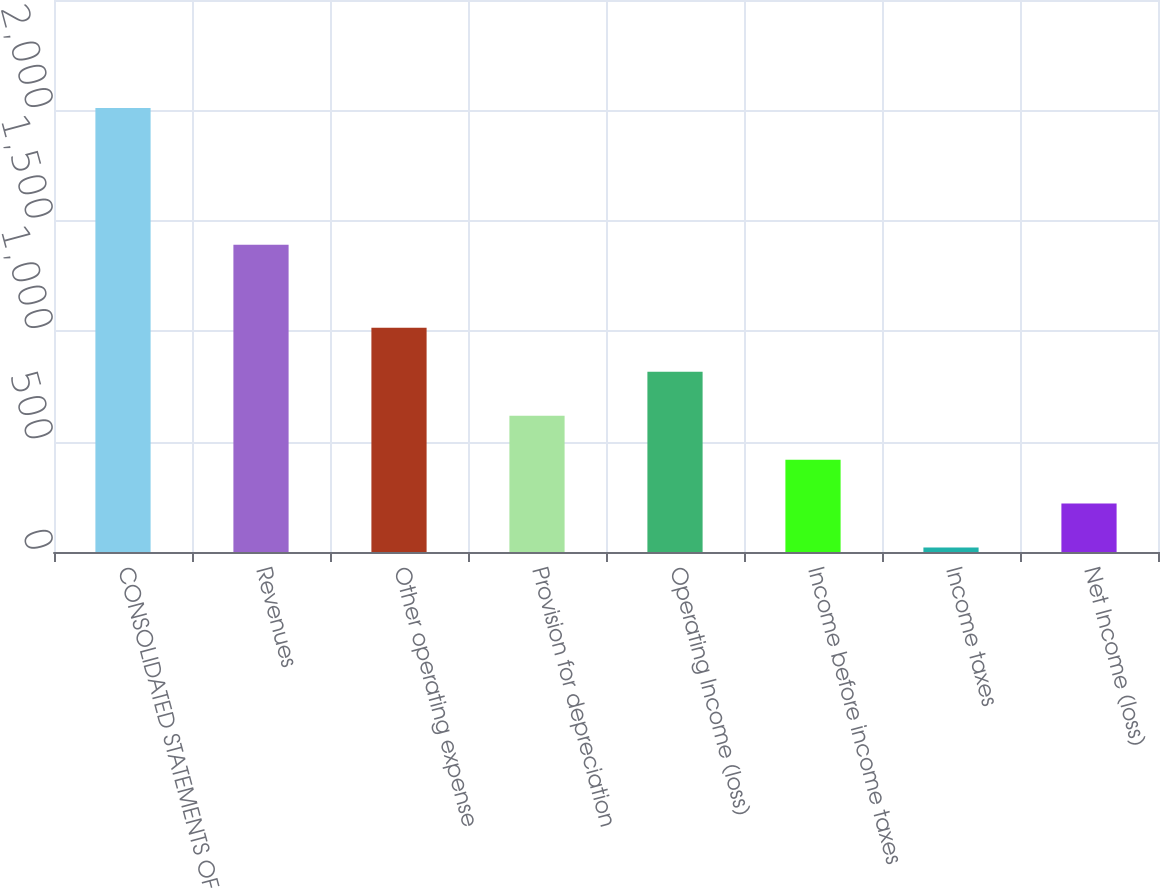<chart> <loc_0><loc_0><loc_500><loc_500><bar_chart><fcel>CONSOLIDATED STATEMENTS OF<fcel>Revenues<fcel>Other operating expense<fcel>Provision for depreciation<fcel>Operating Income (loss)<fcel>Income before income taxes<fcel>Income taxes<fcel>Net Income (loss)<nl><fcel>2011<fcel>1391<fcel>1015.5<fcel>617.3<fcel>816.4<fcel>418.2<fcel>20<fcel>219.1<nl></chart> 